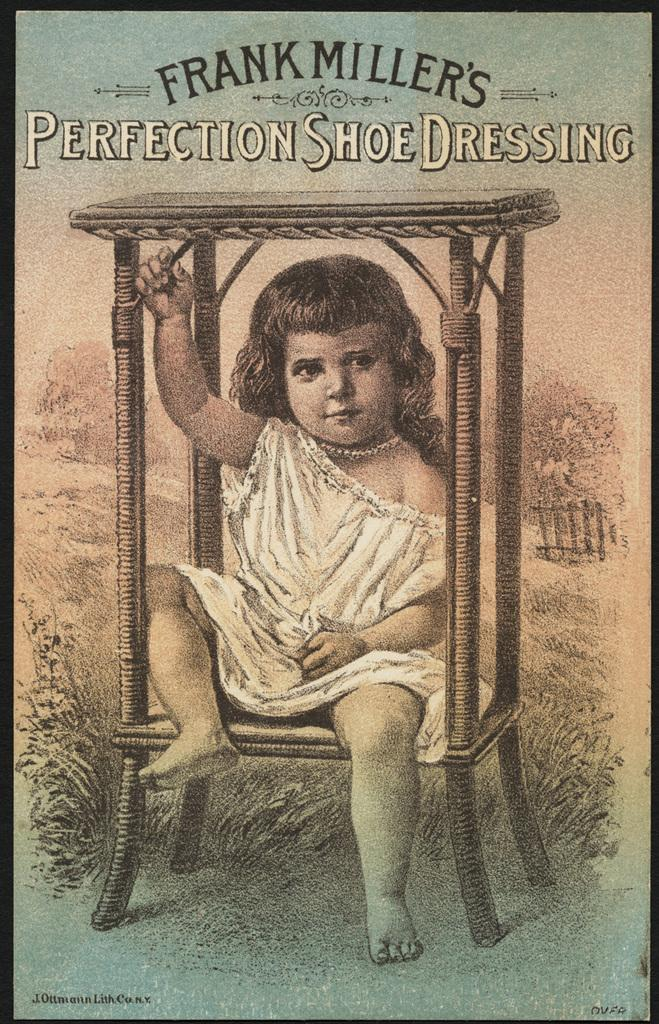<image>
Summarize the visual content of the image. An advertisement for Frank Miller's Perfection Shoe Dressing. 